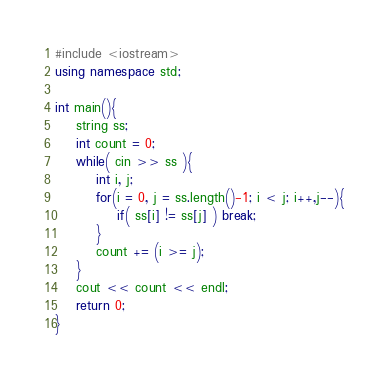Convert code to text. <code><loc_0><loc_0><loc_500><loc_500><_C++_>#include <iostream>
using namespace std;

int main(){
    string ss;
    int count = 0;
    while( cin >> ss ){
        int i, j;
        for(i = 0, j = ss.length()-1; i < j; i++,j--){
            if( ss[i] != ss[j] ) break;
        }
        count += (i >= j);
    }
    cout << count << endl;
    return 0;
}</code> 